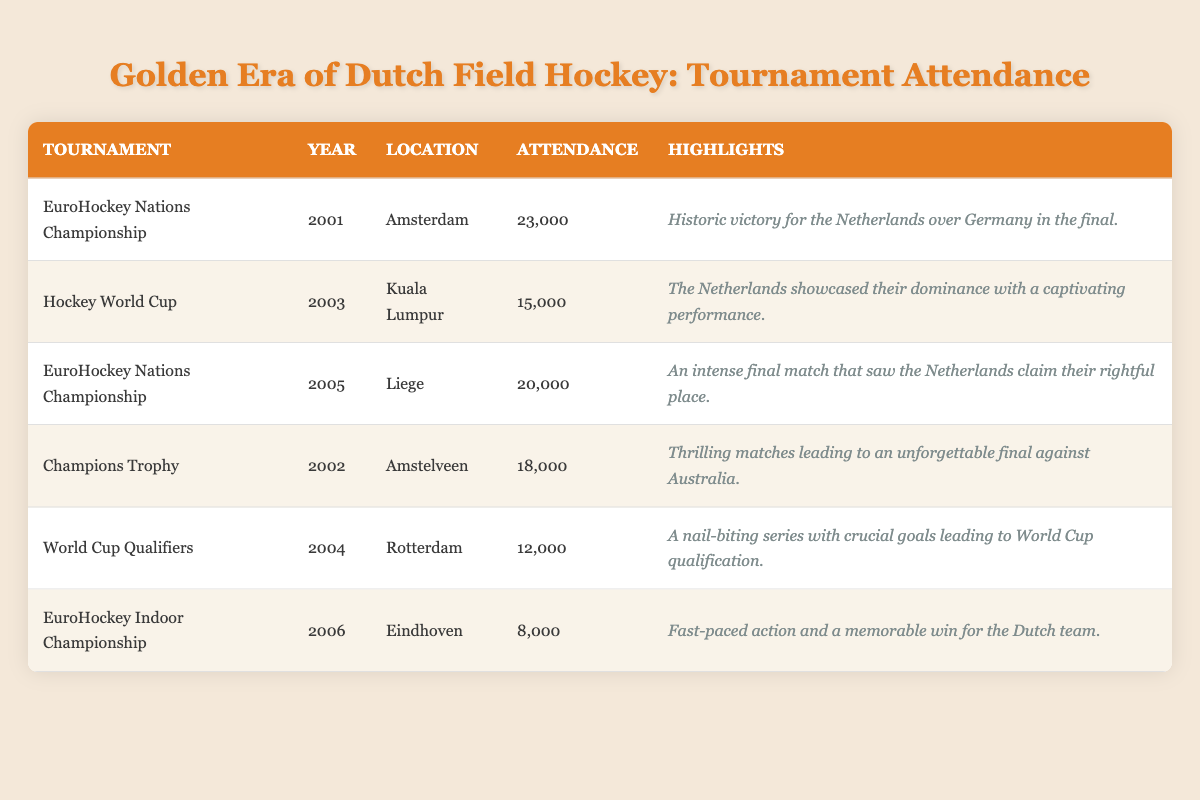What was the highest attendance at a tournament in the early 2000s? The highest attendance listed in the table is 23,000 at the EuroHockey Nations Championship in 2001.
Answer: 23,000 Which tournament had the lowest attendance? The tournament with the lowest attendance is the EuroHockey Indoor Championship in 2006, with 8,000 attendees.
Answer: 8,000 How many attendees were there in total across all six tournaments? To find the total attendance, we sum all the attendance figures: 23,000 + 15,000 + 20,000 + 18,000 + 12,000 + 8,000 = 96,000.
Answer: 96,000 Was there a tournament held in Amstelveen? Yes, there was a tournament held in Amstelveen, which was the Champions Trophy in 2002.
Answer: Yes What is the average attendance for the tournaments listed? To find the average attendance, we need to sum the attendance (96,000) and divide by the number of tournaments, which is 6. Therefore, 96,000 / 6 = 16,000.
Answer: 16,000 Which year had a tournament with more than 20,000 attendees? The year 2001 had a tournament, the EuroHockey Nations Championship, with 23,000 attendees, which is more than 20,000.
Answer: 2001 What percentage of the total attendance did the EuroHockey Indoor Championship represent? The EuroHockey Indoor Championship had 8,000 attendees. To calculate the percentage, we divide 8,000 by the total attendance (96,000) and multiply by 100: (8,000 / 96,000) * 100 = 8.33%.
Answer: 8.33% How many tournaments were held in the Netherlands? The tournaments held in the Netherlands are the EuroHockey Nations Championship (2001), the Champions Trophy (2002), and the World Cup Qualifiers (2004), making a total of 3 tournaments.
Answer: 3 Which two tournaments had an attendance between 15,000 and 20,000? The two tournaments with attendance figures between 15,000 and 20,000 are the Champions Trophy in 2002 (18,000) and the Hockey World Cup in 2003 (15,000).
Answer: Champions Trophy and Hockey World Cup Was there a tournament that recorded exactly 12,000 attendees? Yes, the World Cup Qualifiers in 2004 recorded exactly 12,000 attendees.
Answer: Yes 